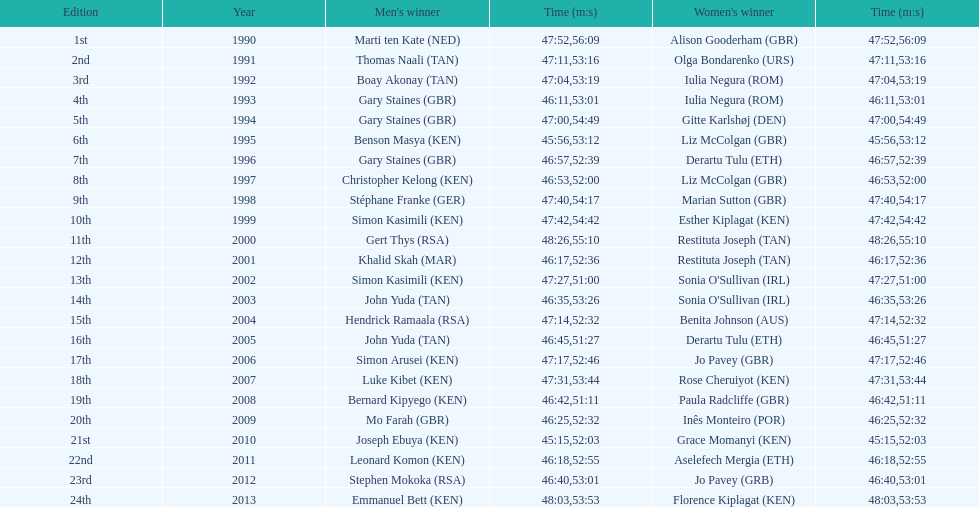For the 2013 bupa great south run, what are the differences in finishing times between men's and women's categories? 5:50. 